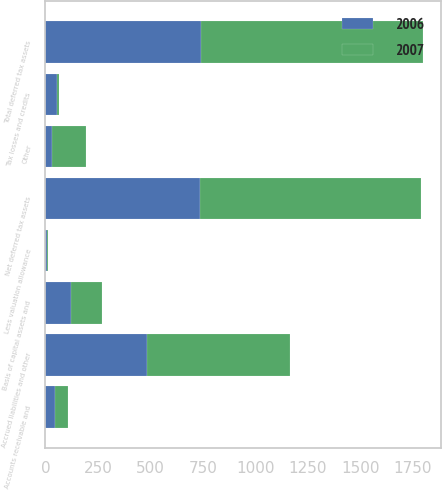Convert chart. <chart><loc_0><loc_0><loc_500><loc_500><stacked_bar_chart><ecel><fcel>Accrued liabilities and other<fcel>Tax losses and credits<fcel>Basis of capital assets and<fcel>Accounts receivable and<fcel>Other<fcel>Total deferred tax assets<fcel>Less valuation allowance<fcel>Net deferred tax assets<nl><fcel>2007<fcel>679<fcel>8<fcel>146<fcel>64<fcel>161<fcel>1058<fcel>5<fcel>1053<nl><fcel>2006<fcel>485<fcel>55<fcel>124<fcel>45<fcel>30<fcel>739<fcel>5<fcel>734<nl></chart> 